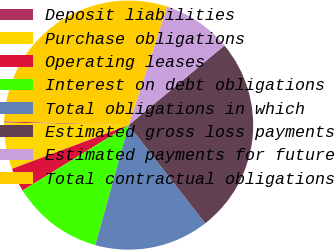Convert chart. <chart><loc_0><loc_0><loc_500><loc_500><pie_chart><fcel>Deposit liabilities<fcel>Purchase obligations<fcel>Operating leases<fcel>Interest on debt obligations<fcel>Total obligations in which<fcel>Estimated gross loss payments<fcel>Estimated payments for future<fcel>Total contractual obligations<nl><fcel>0.16%<fcel>6.03%<fcel>3.09%<fcel>11.9%<fcel>14.84%<fcel>25.5%<fcel>8.96%<fcel>29.52%<nl></chart> 